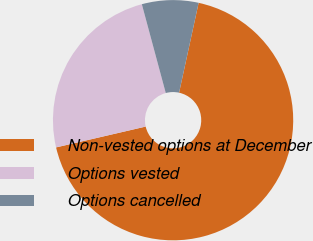<chart> <loc_0><loc_0><loc_500><loc_500><pie_chart><fcel>Non-vested options at December<fcel>Options vested<fcel>Options cancelled<nl><fcel>67.96%<fcel>24.45%<fcel>7.6%<nl></chart> 